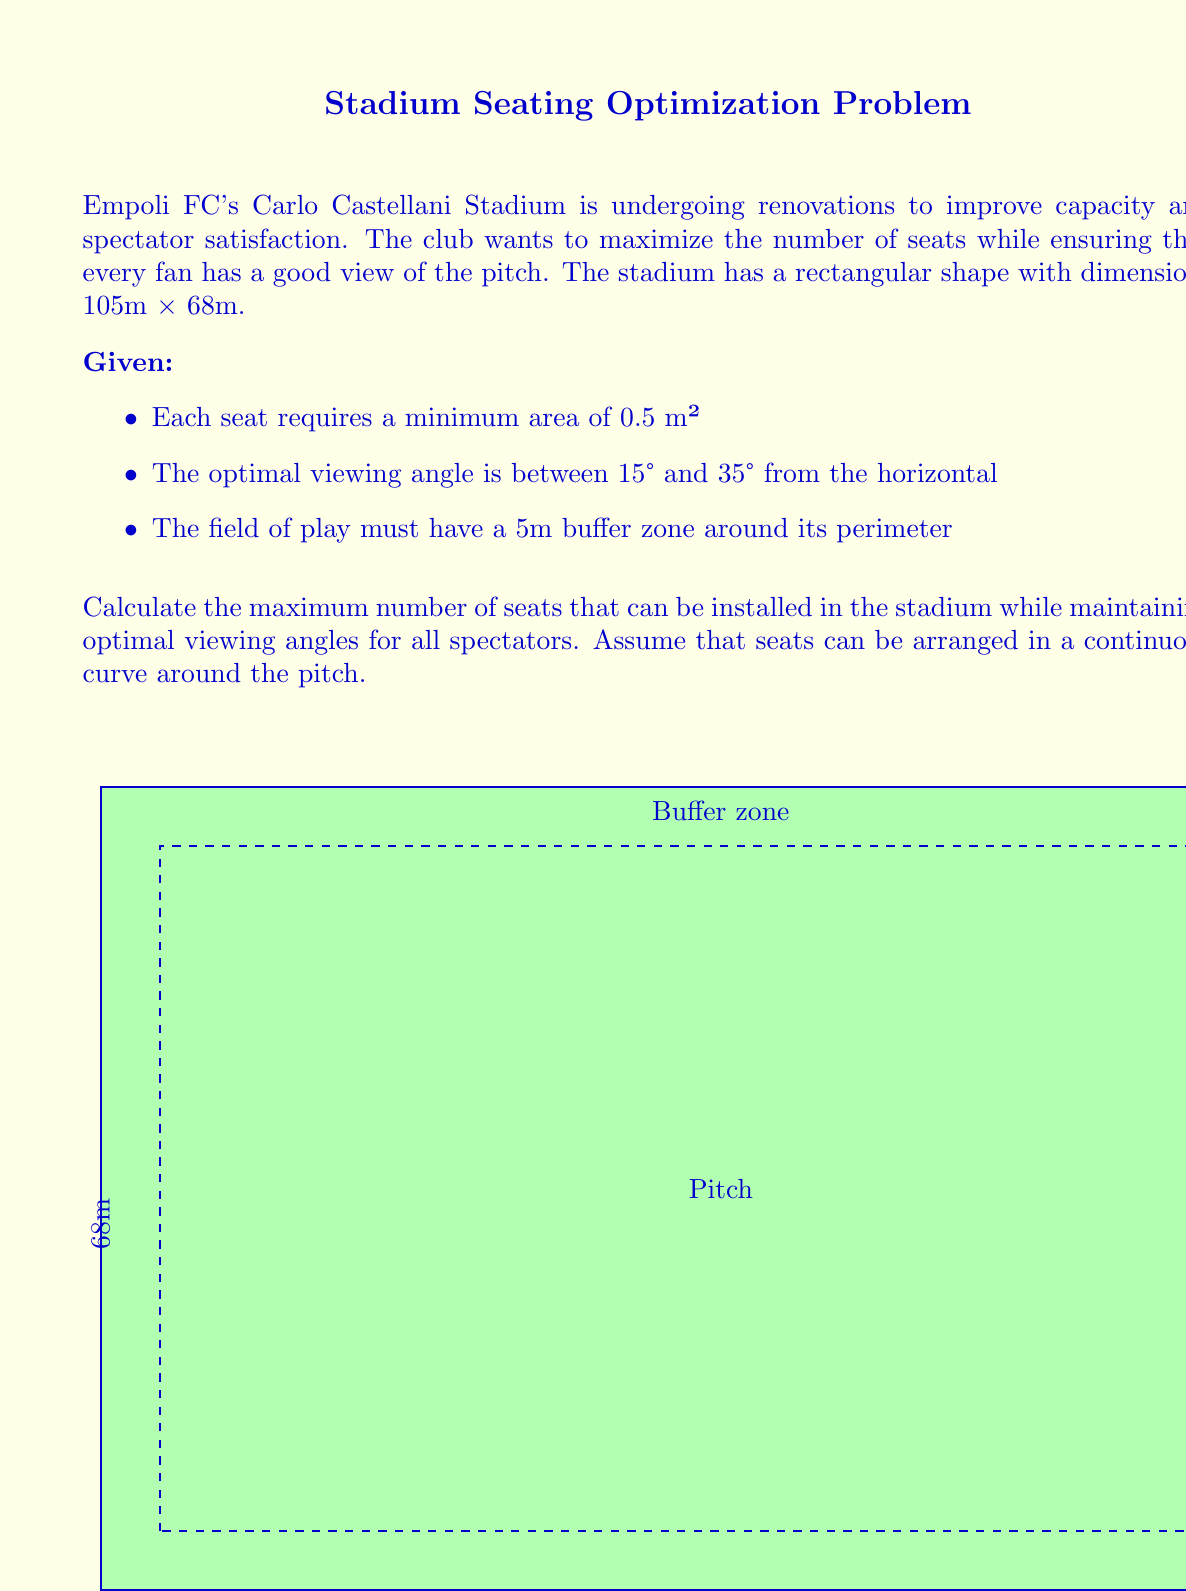Can you answer this question? Let's approach this problem step by step:

1) First, we need to calculate the area available for seating:
   - Total stadium area: $105 \times 68 = 7140$ m²
   - Pitch area (including buffer): $(105 + 2 \times 5) \times (68 + 2 \times 5) = 8775$ m²
   - Available seating area: $7140 - 8775 = -1635$ m²

   This negative result indicates that we need to build upwards, not outwards.

2) To maximize capacity while maintaining good viewing angles, we'll use a continuous curve seating arrangement. The optimal curve can be approximated by a logarithmic spiral.

3) The equation for a logarithmic spiral in polar coordinates is:
   $r = a \cdot e^{b\theta}$
   where $r$ is the radius, $\theta$ is the angle, and $a$ and $b$ are constants.

4) We need to set the parameters to ensure the viewing angle stays between 15° and 35°:
   $\tan(\alpha) = \frac{1}{b}$, where $\alpha$ is the viewing angle
   For 15°: $b_{\text{max}} = \frac{1}{\tan(15°)} \approx 3.73$
   For 35°: $b_{\text{min}} = \frac{1}{\tan(35°)} \approx 1.43$

5) We'll use the average: $b = \frac{3.73 + 1.43}{2} \approx 2.58$

6) The parameter $a$ determines the starting radius. We'll set it to half the pitch width plus the buffer: $a = 34 + 5 = 39$ m

7) The maximum radius is half the stadium length: $52.5$ m
   We can find the maximum angle $\theta_{\text{max}}$ using:
   $52.5 = 39 \cdot e^{2.58\theta_{\text{max}}}$
   $\theta_{\text{max}} = \frac{\ln(52.5/39)}{2.58} \approx 0.29$ radians

8) The length of the spiral can be calculated using:
   $L = \frac{a}{b}\sqrt{1+b^2}(e^{b\theta_{\text{max}}} - 1) \approx 36.8$ m

9) Given that each seat requires 0.5 m², and we have four such spirals (one in each corner), the total number of seats is:
   $N = \frac{4 \times 36.8}{0.5} = 294.4$

10) Rounding down to ensure all seats have good views:
Answer: 294 seats 